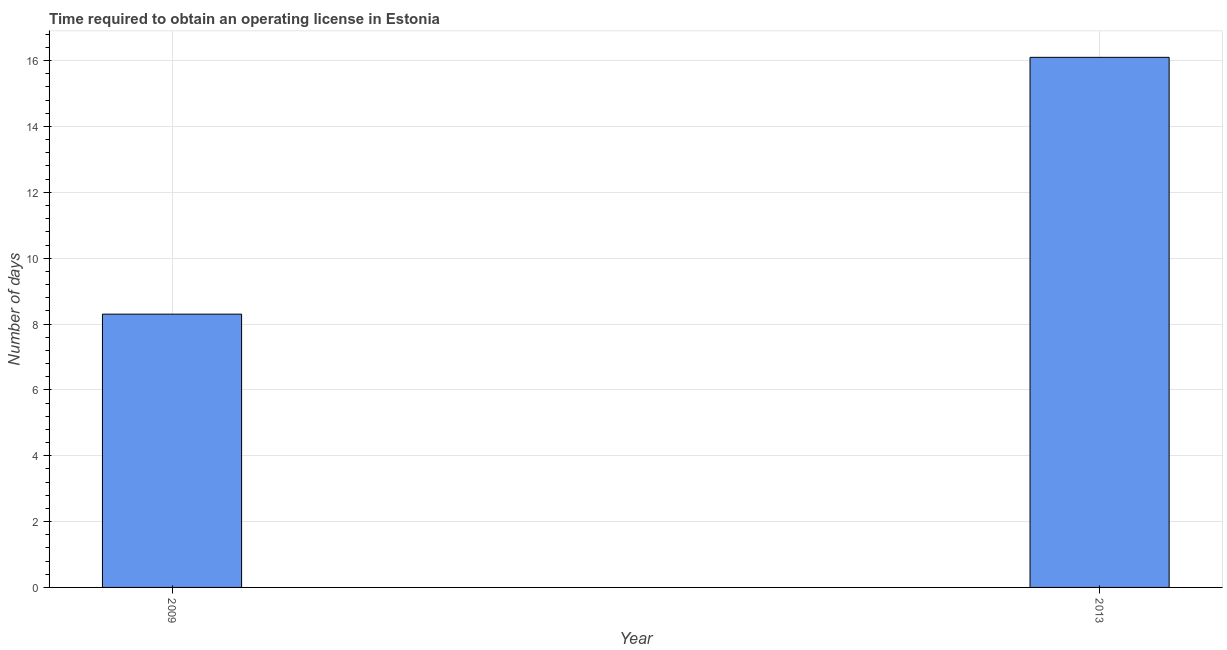Does the graph contain any zero values?
Make the answer very short. No. Does the graph contain grids?
Your answer should be compact. Yes. What is the title of the graph?
Offer a very short reply. Time required to obtain an operating license in Estonia. What is the label or title of the Y-axis?
Make the answer very short. Number of days. Across all years, what is the maximum number of days to obtain operating license?
Keep it short and to the point. 16.1. What is the sum of the number of days to obtain operating license?
Your answer should be very brief. 24.4. What is the average number of days to obtain operating license per year?
Keep it short and to the point. 12.2. What is the median number of days to obtain operating license?
Provide a succinct answer. 12.2. What is the ratio of the number of days to obtain operating license in 2009 to that in 2013?
Your answer should be very brief. 0.52. Is the number of days to obtain operating license in 2009 less than that in 2013?
Provide a succinct answer. Yes. In how many years, is the number of days to obtain operating license greater than the average number of days to obtain operating license taken over all years?
Provide a short and direct response. 1. How many bars are there?
Keep it short and to the point. 2. Are all the bars in the graph horizontal?
Your answer should be compact. No. What is the Number of days in 2013?
Give a very brief answer. 16.1. What is the ratio of the Number of days in 2009 to that in 2013?
Your answer should be very brief. 0.52. 